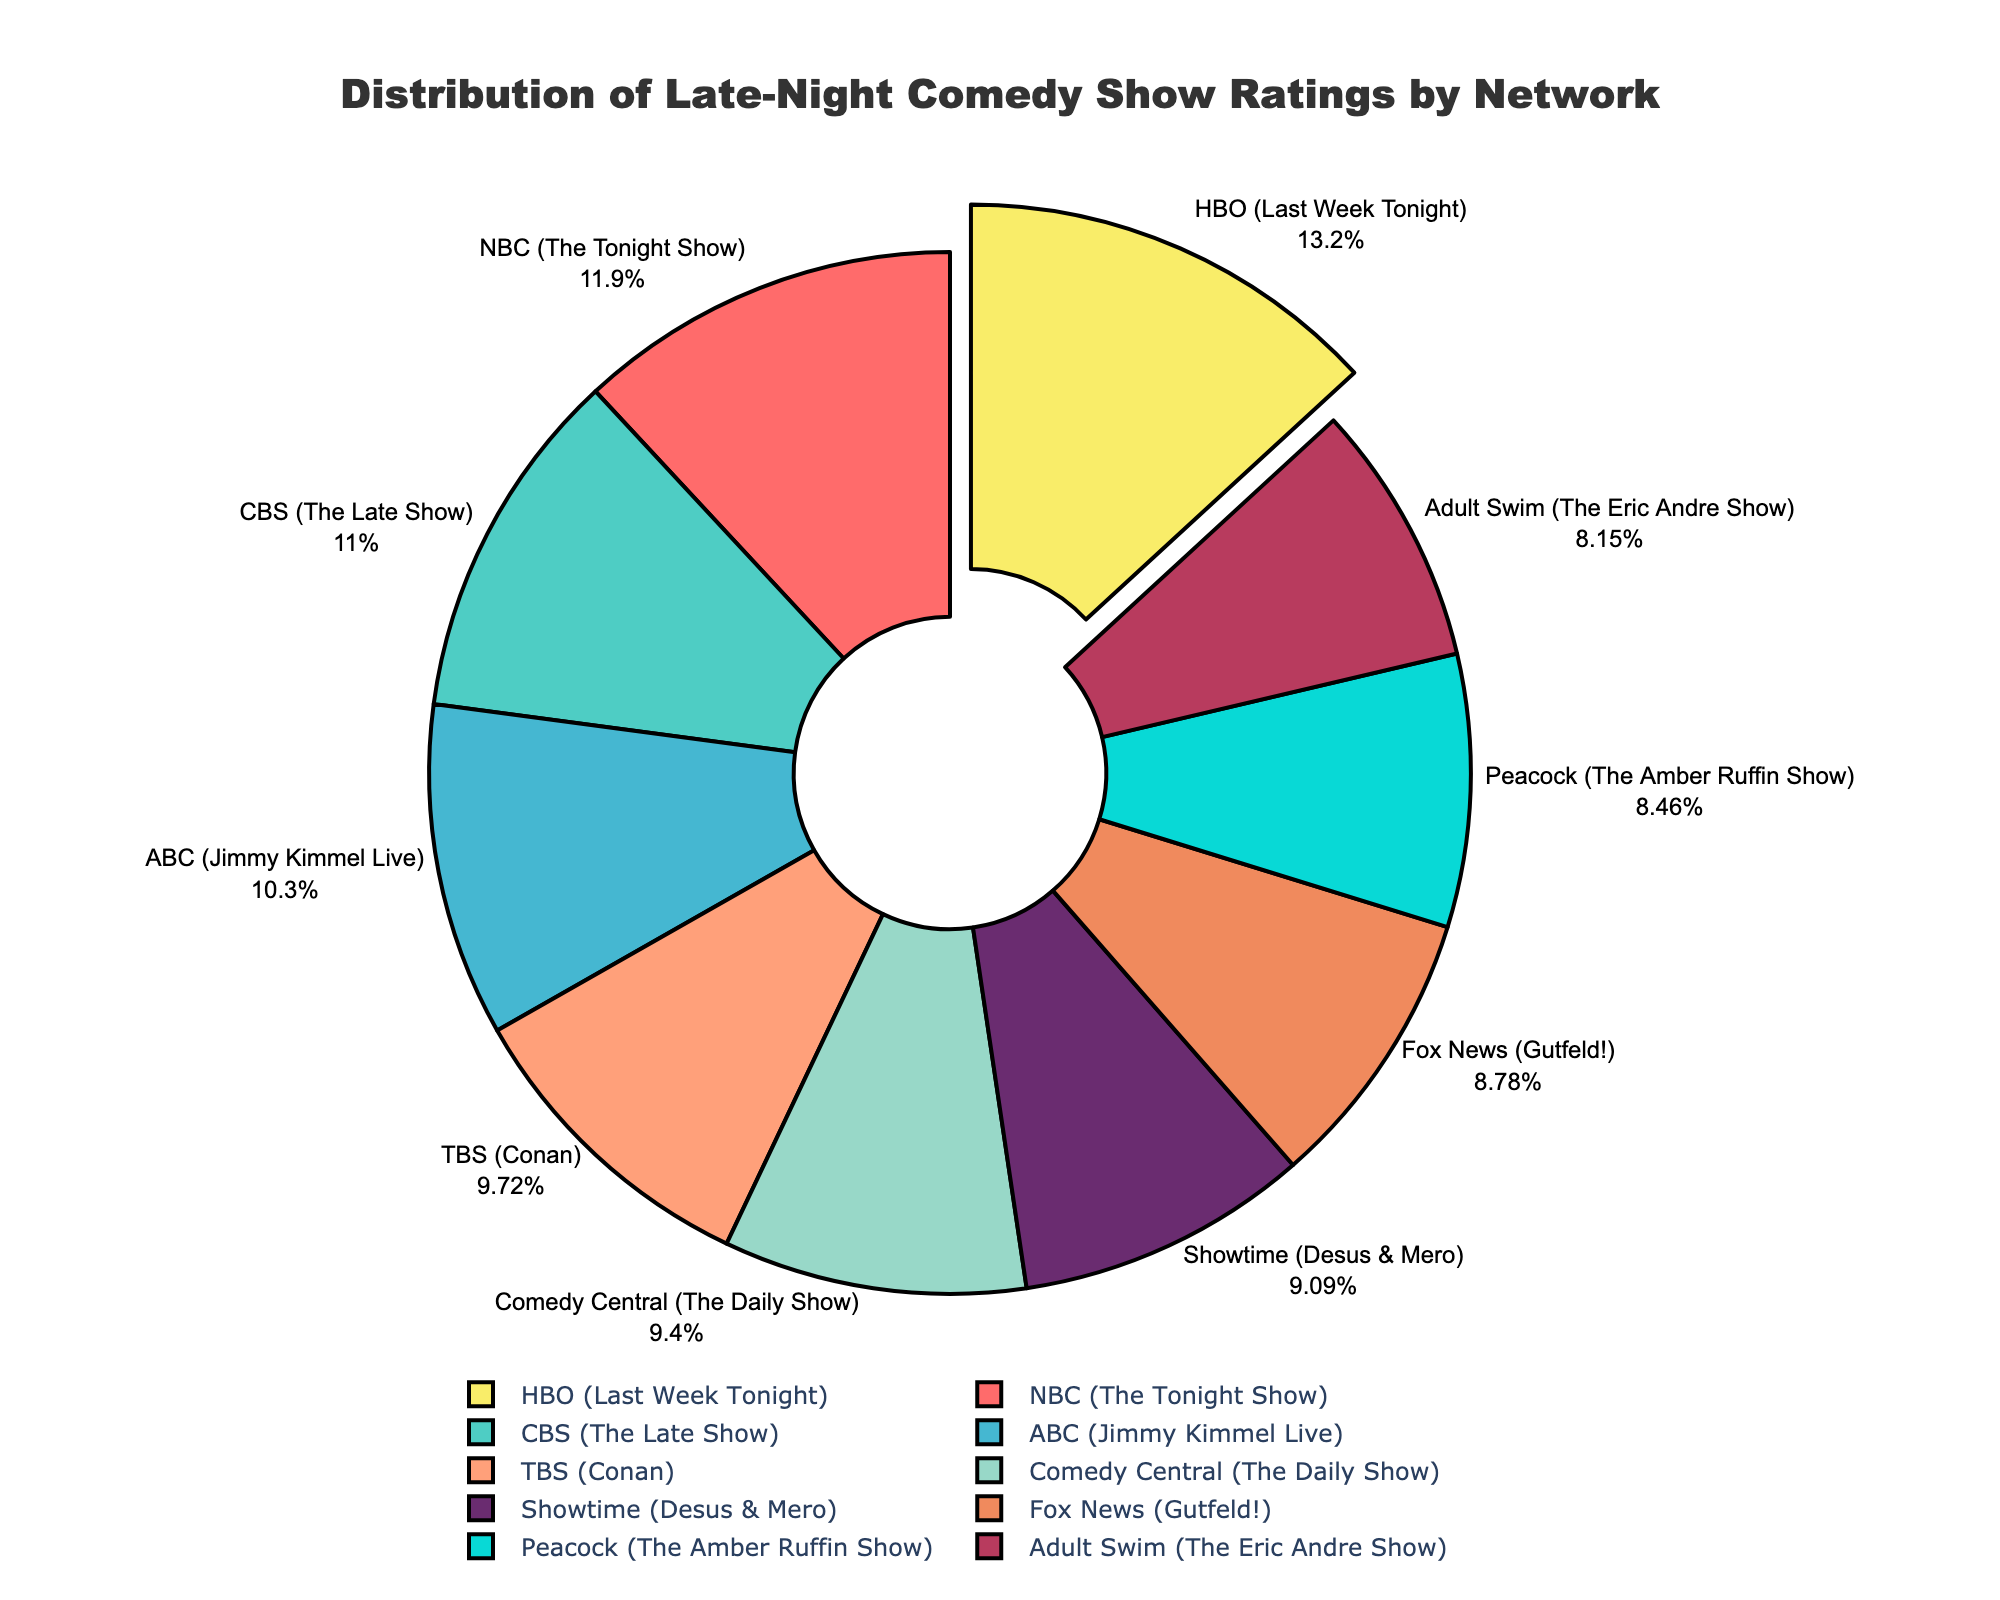Which network has the highest average rating? The network with the highest average rating will have a segment pulled out of the pie chart since the code pulls the segment with the maximum value. Observing the chart, the segment with the highest rating is pulled out.
Answer: HBO (Last Week Tonight) Which network has the lowest average rating? To find the network with the lowest rating, identify the segment on the pie chart with the smallest proportion. Observing the chart, the network with the smallest rating segment is Adult Swim (The Eric Andre Show).
Answer: Adult Swim (The Eric Andre Show) How much higher is HBO's (Last Week Tonight) rating compared to ABC’s (Jimmy Kimmel Live)? HBO’s average rating is 4.2 and ABC’s average rating is 3.3. Subtract ABC’s rating from HBO’s rating: 4.2 - 3.3 = 0.9.
Answer: 0.9 Which network has a rating closest to the average rating of NBC (The Tonight Show) and CBS (The Late Show)? First, calculate the average of NBC (3.8) and CBS (3.5): (3.8 + 3.5) / 2 = 3.65. Then, find the network with the rating closest to 3.65 by comparing the values.
Answer: ABC (Jimmy Kimmel Live) What is the combined rating for Fox News (Gutfeld!) and Showtime (Desus & Mero)? Add the ratings for Fox News and Showtime: 2.8 (Fox News) + 2.9 (Showtime) = 5.7.
Answer: 5.7 Which network has a higher rating: NBC (The Tonight Show) or CBS (The Late Show)? Compare the ratings of NBC and CBS. NBC has a rating of 3.8 while CBS has a rating of 3.5, so NBC has a higher rating.
Answer: NBC (The Tonight Show) What is the average rating of all networks listed? Sum up all the ratings and divide by the number of networks. (3.8 + 3.5 + 3.3 + 3.1 + 3.0 + 4.2 + 2.8 + 2.6 + 2.9 + 2.7) / 10 = 31.9 / 10 = 3.19.
Answer: 3.19 Which network's segment appears in blue on the pie chart? To determine the network with the blue segment, observe the pie chart colors and match the blue segment to its corresponding label.
Answer: TBS (Conan) How much higher is the average rating for HBO (Last Week Tonight) than the overall average rating? Calculate the overall average rating first (3.19), then subtract it from HBO’s rating: 4.2 - 3.19 = 1.01.
Answer: 1.01 If you combine the ratings of ABC (Jimmy Kimmel Live) and Comedy Central (The Daily Show), is their total higher than NBC (The Tonight Show) and CBS (The Late Show) combined? Calculate both sums first: ABC + Comedy Central = 3.3 + 3.0 = 6.3, and NBC + CBS = 3.8 + 3.5 = 7.3. Compare the totals: 6.3 < 7.3.
Answer: No 